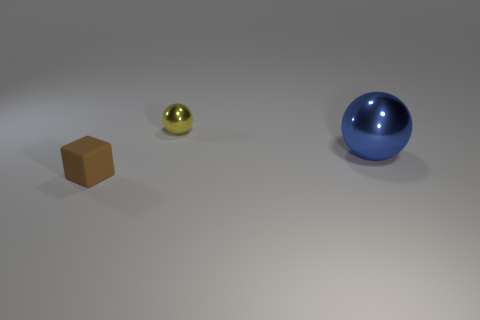Subtract all yellow spheres. How many spheres are left? 1 Add 2 tiny rubber things. How many objects exist? 5 Subtract all spheres. How many objects are left? 1 Subtract all purple spheres. Subtract all purple cylinders. How many spheres are left? 2 Subtract all cyan cubes. How many green spheres are left? 0 Subtract all big spheres. Subtract all shiny balls. How many objects are left? 0 Add 1 large blue metal objects. How many large blue metal objects are left? 2 Add 2 big purple matte spheres. How many big purple matte spheres exist? 2 Subtract 0 purple cylinders. How many objects are left? 3 